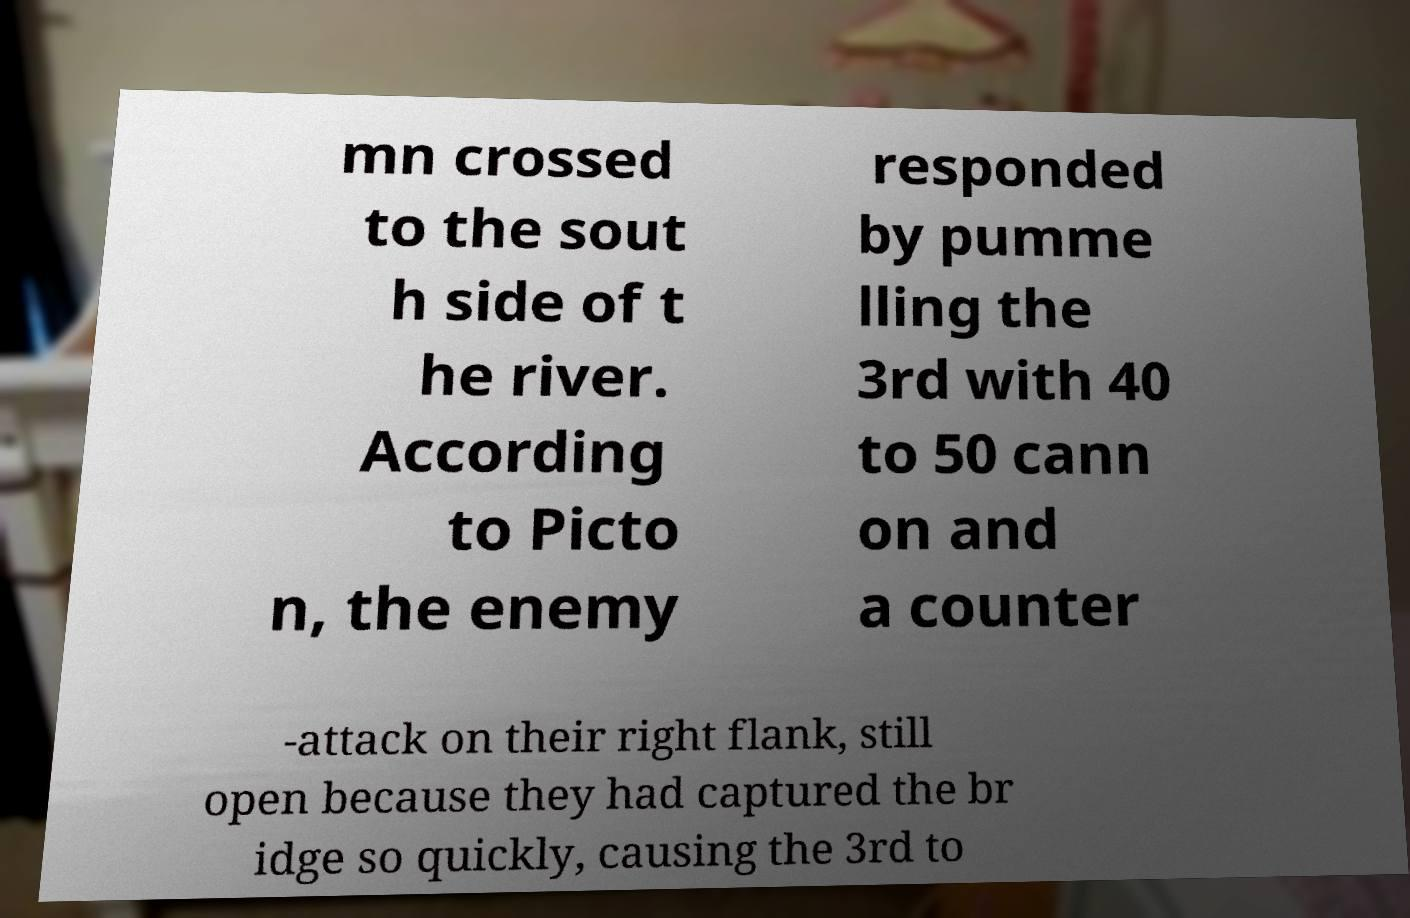Please identify and transcribe the text found in this image. mn crossed to the sout h side of t he river. According to Picto n, the enemy responded by pumme lling the 3rd with 40 to 50 cann on and a counter -attack on their right flank, still open because they had captured the br idge so quickly, causing the 3rd to 